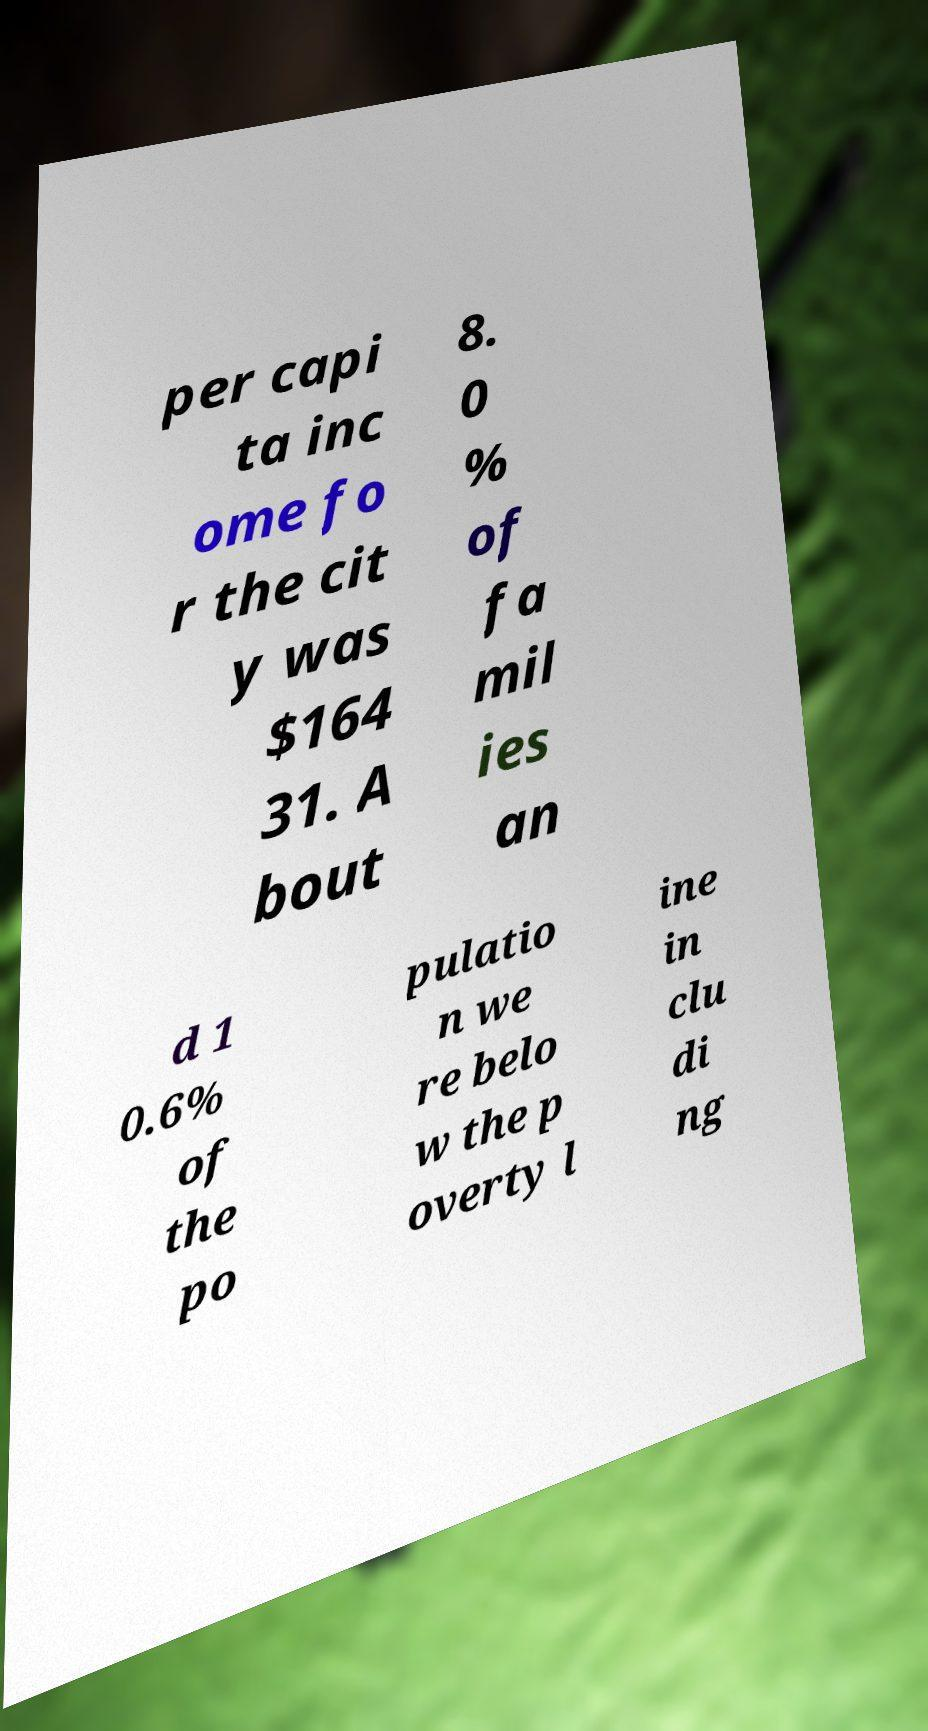For documentation purposes, I need the text within this image transcribed. Could you provide that? per capi ta inc ome fo r the cit y was $164 31. A bout 8. 0 % of fa mil ies an d 1 0.6% of the po pulatio n we re belo w the p overty l ine in clu di ng 